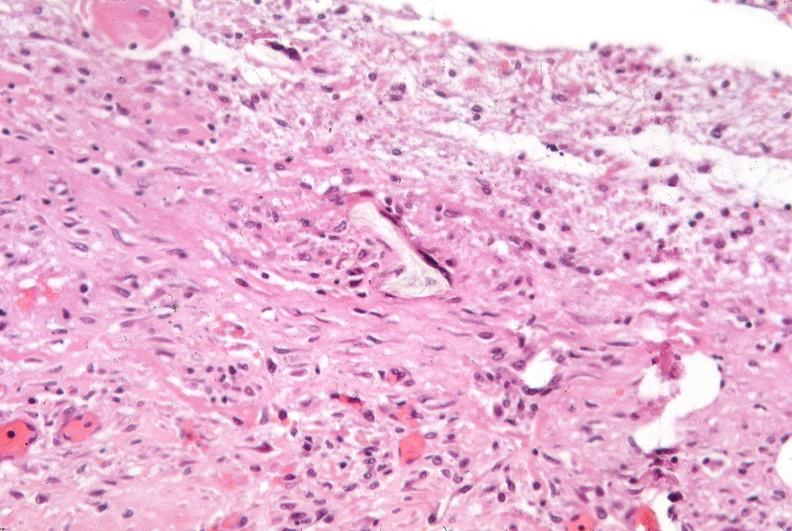what does this image show?
Answer the question using a single word or phrase. Pleura 